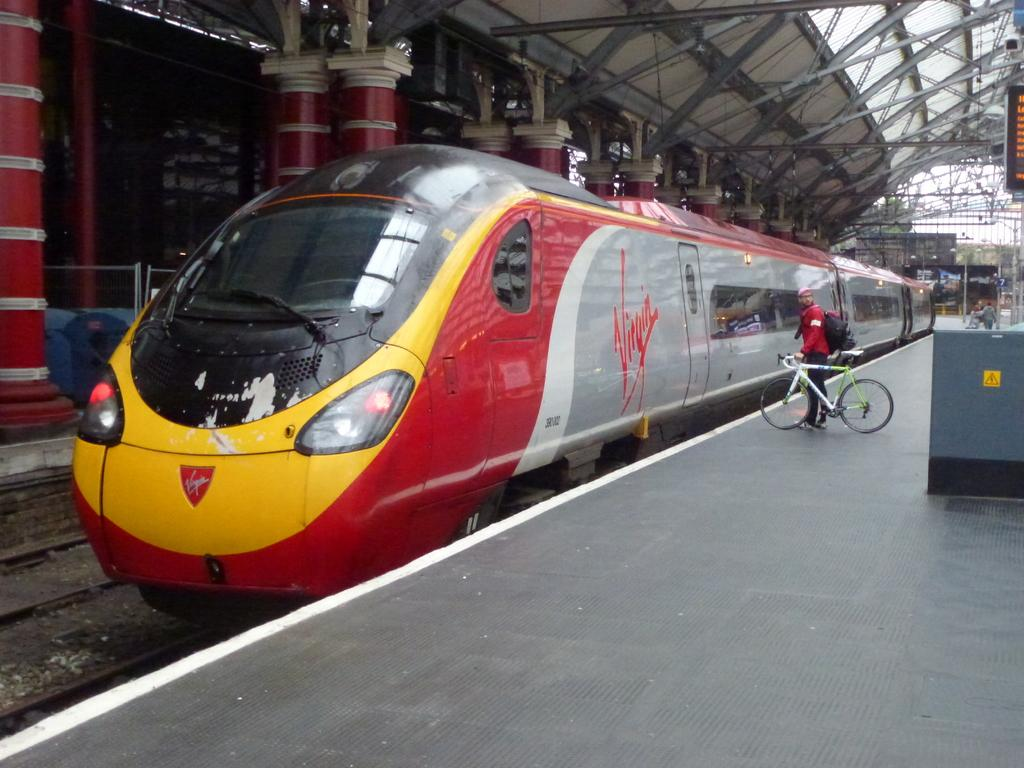<image>
Summarize the visual content of the image. A train sits at the station with the word Virgin written on the side 